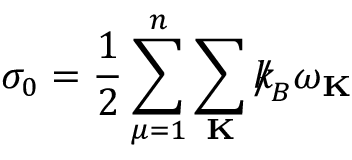Convert formula to latex. <formula><loc_0><loc_0><loc_500><loc_500>\sigma _ { 0 } = \frac { 1 } { 2 } \sum _ { \mu = 1 } ^ { n } \sum _ { K } { \slash \, k } _ { \, { B } } \omega _ { K }</formula> 